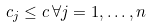<formula> <loc_0><loc_0><loc_500><loc_500>c _ { j } \leq c \, \forall j = 1 , \dots , n</formula> 